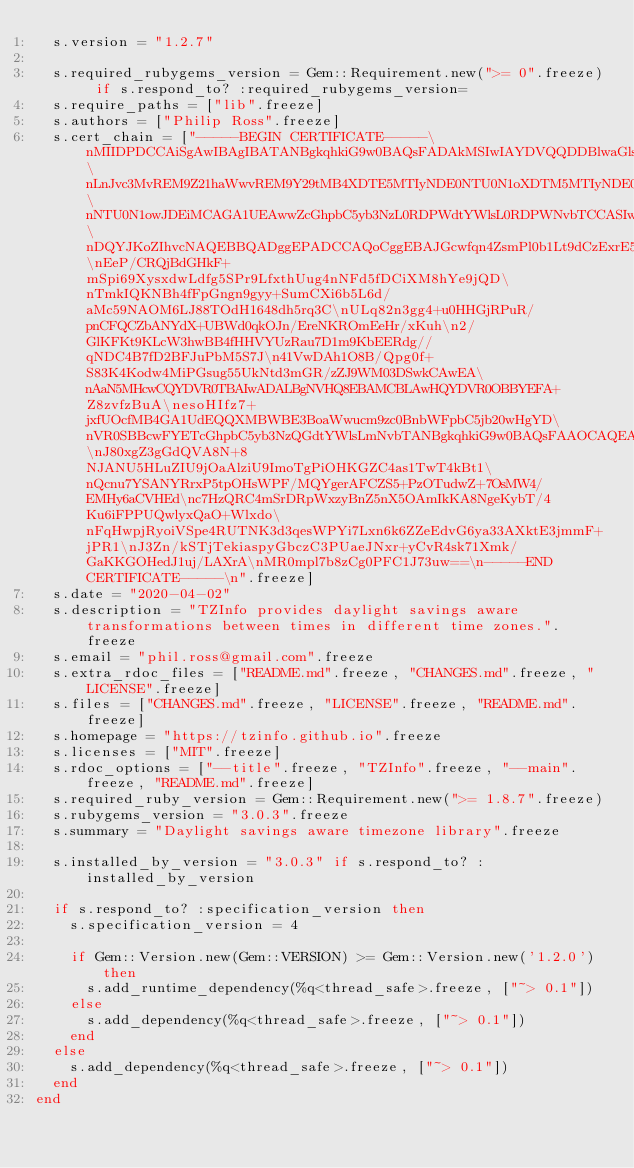<code> <loc_0><loc_0><loc_500><loc_500><_Ruby_>  s.version = "1.2.7"

  s.required_rubygems_version = Gem::Requirement.new(">= 0".freeze) if s.respond_to? :required_rubygems_version=
  s.require_paths = ["lib".freeze]
  s.authors = ["Philip Ross".freeze]
  s.cert_chain = ["-----BEGIN CERTIFICATE-----\nMIIDPDCCAiSgAwIBAgIBATANBgkqhkiG9w0BAQsFADAkMSIwIAYDVQQDDBlwaGls\nLnJvc3MvREM9Z21haWwvREM9Y29tMB4XDTE5MTIyNDE0NTU0N1oXDTM5MTIyNDE0\nNTU0N1owJDEiMCAGA1UEAwwZcGhpbC5yb3NzL0RDPWdtYWlsL0RDPWNvbTCCASIw\nDQYJKoZIhvcNAQEBBQADggEPADCCAQoCggEBAJGcwfqn4ZsmPl0b1Lt9dCzExrE5\nEeP/CRQjBdGHkF+mSpi69XysxdwLdfg5SPr9LfxthUug4nNFd5fDCiXM8hYe9jQD\nTmkIQKNBh4fFpGngn9gyy+SumCXi6b5L6d/aMc59NAOM6LJ88TOdH1648dh5rq3C\nULq82n3gg4+u0HHGjRPuR/pnCFQCZbANYdX+UBWd0qkOJn/EreNKROmEeHr/xKuh\n2/GlKFKt9KLcW3hwBB4fHHVYUzRau7D1m9KbEERdg//qNDC4B7fD2BFJuPbM5S7J\n41VwDAh1O8B/Qpg0f+S83K4Kodw4MiPGsug55UkNtd3mGR/zZJ9WM03DSwkCAwEA\nAaN5MHcwCQYDVR0TBAIwADALBgNVHQ8EBAMCBLAwHQYDVR0OBBYEFA+Z8zvfzBuA\nesoHIfz7+jxfUOcfMB4GA1UdEQQXMBWBE3BoaWwucm9zc0BnbWFpbC5jb20wHgYD\nVR0SBBcwFYETcGhpbC5yb3NzQGdtYWlsLmNvbTANBgkqhkiG9w0BAQsFAAOCAQEA\nJ80xgZ3gGdQVA8N+8NJANU5HLuZIU9jOaAlziU9ImoTgPiOHKGZC4as1TwT4kBt1\nQcnu7YSANYRrxP5tpOHsWPF/MQYgerAFCZS5+PzOTudwZ+7OsMW4/EMHy6aCVHEd\nc7HzQRC4mSrDRpWxzyBnZ5nX5OAmIkKA8NgeKybT/4Ku6iFPPUQwlyxQaO+Wlxdo\nFqHwpjRyoiVSpe4RUTNK3d3qesWPYi7Lxn6k6ZZeEdvG6ya33AXktE3jmmF+jPR1\nJ3Zn/kSTjTekiaspyGbczC3PUaeJNxr+yCvR4sk71Xmk/GaKKGOHedJ1uj/LAXrA\nMR0mpl7b8zCg0PFC1J73uw==\n-----END CERTIFICATE-----\n".freeze]
  s.date = "2020-04-02"
  s.description = "TZInfo provides daylight savings aware transformations between times in different time zones.".freeze
  s.email = "phil.ross@gmail.com".freeze
  s.extra_rdoc_files = ["README.md".freeze, "CHANGES.md".freeze, "LICENSE".freeze]
  s.files = ["CHANGES.md".freeze, "LICENSE".freeze, "README.md".freeze]
  s.homepage = "https://tzinfo.github.io".freeze
  s.licenses = ["MIT".freeze]
  s.rdoc_options = ["--title".freeze, "TZInfo".freeze, "--main".freeze, "README.md".freeze]
  s.required_ruby_version = Gem::Requirement.new(">= 1.8.7".freeze)
  s.rubygems_version = "3.0.3".freeze
  s.summary = "Daylight savings aware timezone library".freeze

  s.installed_by_version = "3.0.3" if s.respond_to? :installed_by_version

  if s.respond_to? :specification_version then
    s.specification_version = 4

    if Gem::Version.new(Gem::VERSION) >= Gem::Version.new('1.2.0') then
      s.add_runtime_dependency(%q<thread_safe>.freeze, ["~> 0.1"])
    else
      s.add_dependency(%q<thread_safe>.freeze, ["~> 0.1"])
    end
  else
    s.add_dependency(%q<thread_safe>.freeze, ["~> 0.1"])
  end
end
</code> 